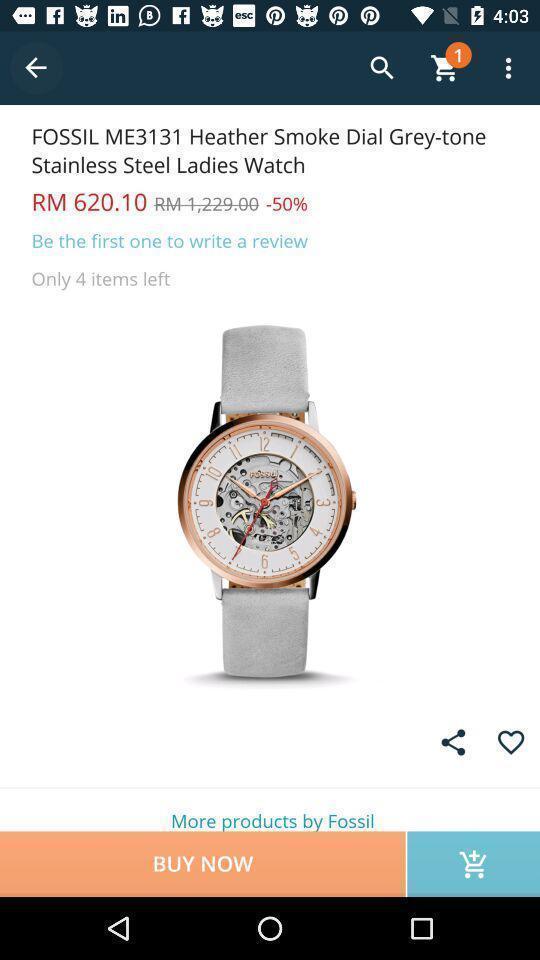What details can you identify in this image? Page that displaying shopping application. 